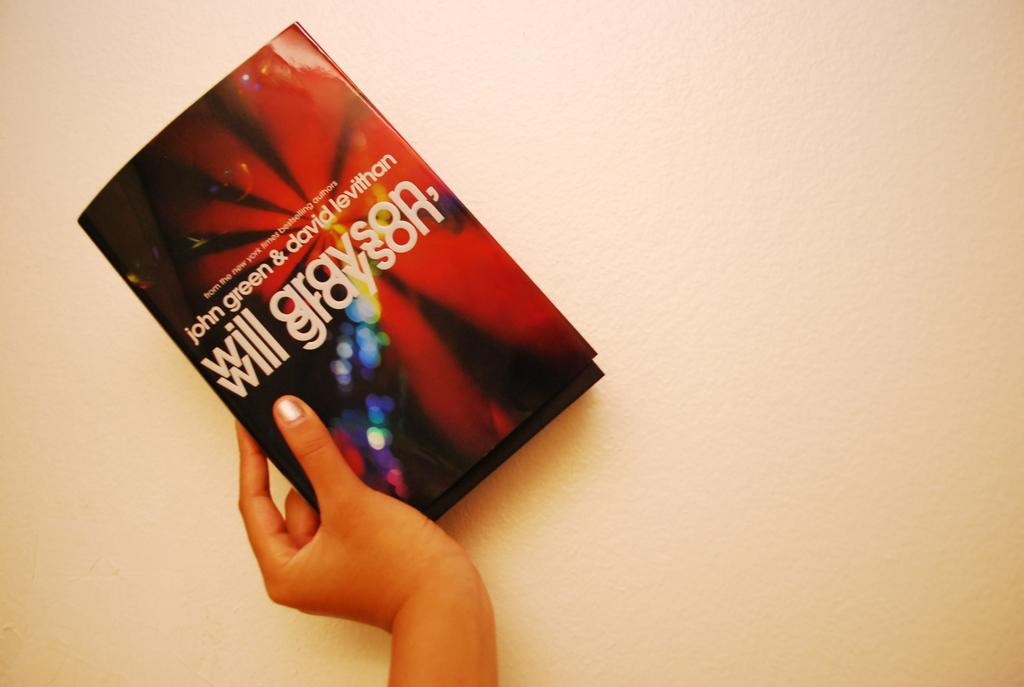<image>
Provide a brief description of the given image. A woman has her hand on a book titled Will Gravson, Will Gravson. 